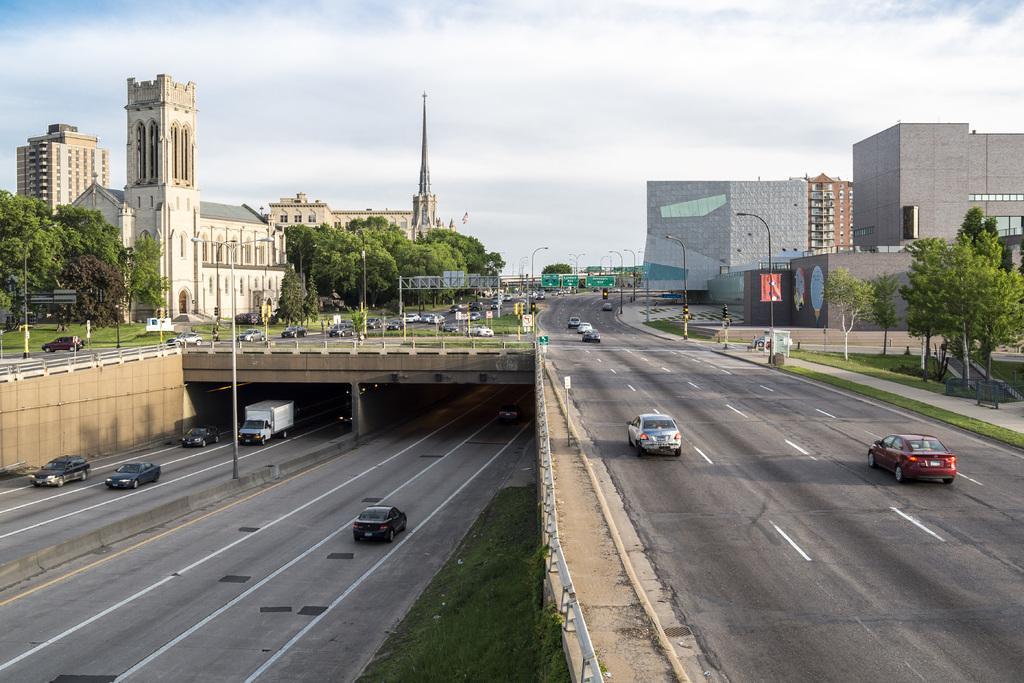Can you describe this image briefly? In the image there are vehicles going on road on either sides, in the back there are buildings on either side of land with trees in front of it and above its sky with clouds. 